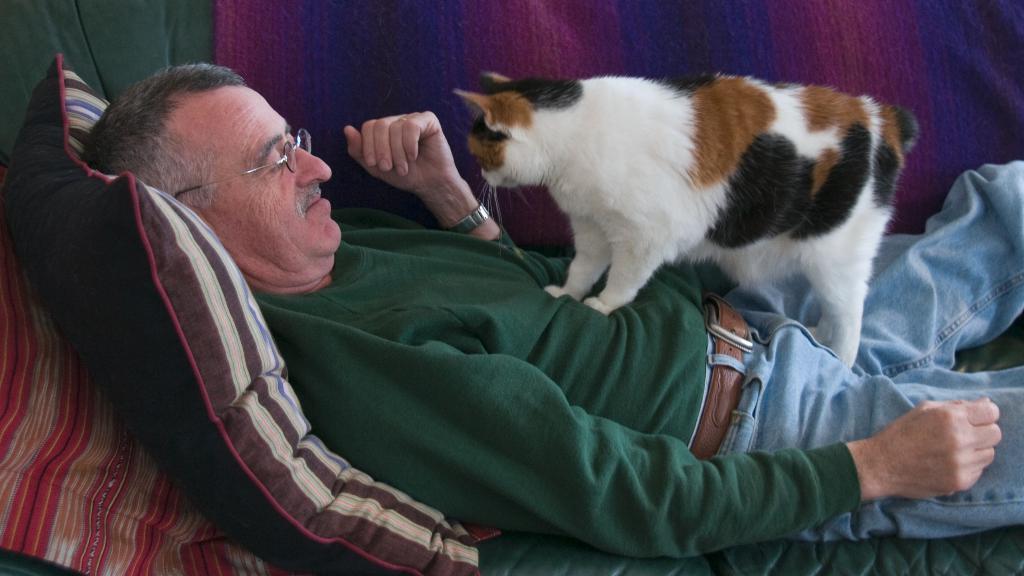In one or two sentences, can you explain what this image depicts? In this picture we can see a person is lying on the cot, and the cat is standing on his stomach, and here is the pillow at the back. 